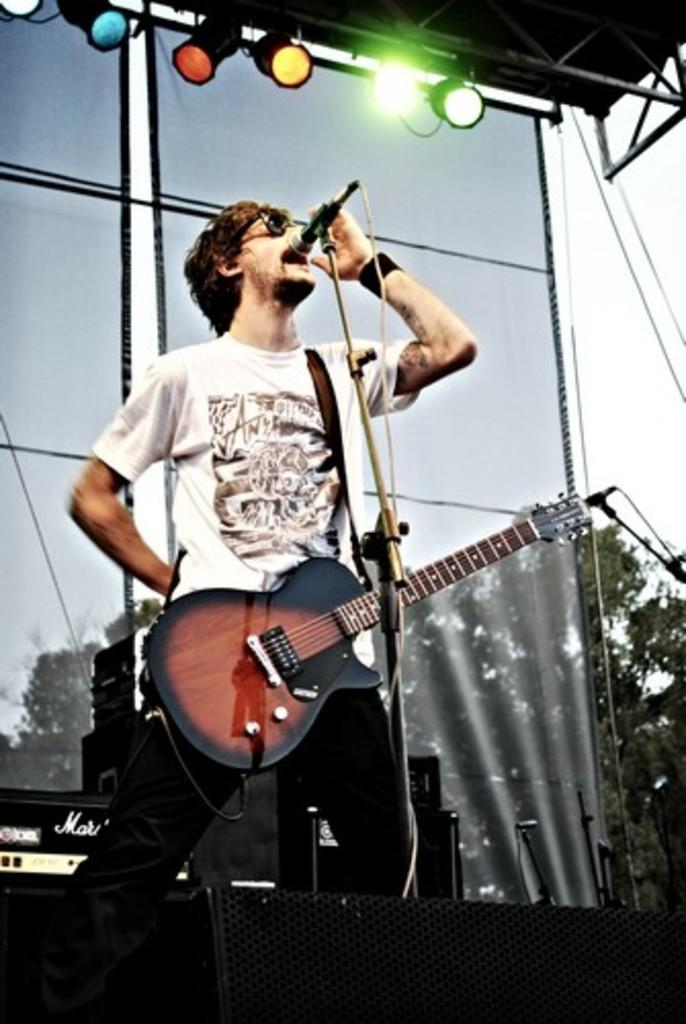What is the main subject of the image? The main subject of the image is a man. What is the man doing in the image? The man is standing and singing a song. What is the man wearing in the image? The man is wearing a guitar. What can be seen in the background of the image? In the background, there are speakers, trees, the sky, focus lights, and iron rods. What type of question is the man asking in the image? There is no indication in the image that the man is asking a question; he is singing a song. What type of prose is the man reciting in the image? The man is singing a song, not reciting prose, in the image. 